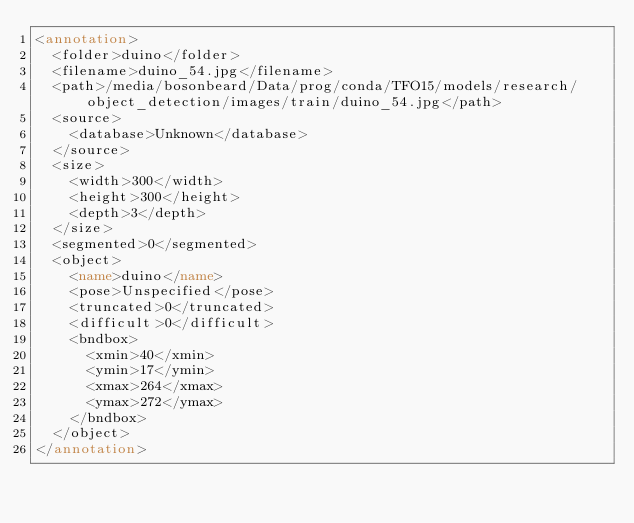<code> <loc_0><loc_0><loc_500><loc_500><_XML_><annotation>
	<folder>duino</folder>
	<filename>duino_54.jpg</filename>
	<path>/media/bosonbeard/Data/prog/conda/TFO15/models/research/object_detection/images/train/duino_54.jpg</path>
	<source>
		<database>Unknown</database>
	</source>
	<size>
		<width>300</width>
		<height>300</height>
		<depth>3</depth>
	</size>
	<segmented>0</segmented>
	<object>
		<name>duino</name>
		<pose>Unspecified</pose>
		<truncated>0</truncated>
		<difficult>0</difficult>
		<bndbox>
			<xmin>40</xmin>
			<ymin>17</ymin>
			<xmax>264</xmax>
			<ymax>272</ymax>
		</bndbox>
	</object>
</annotation></code> 